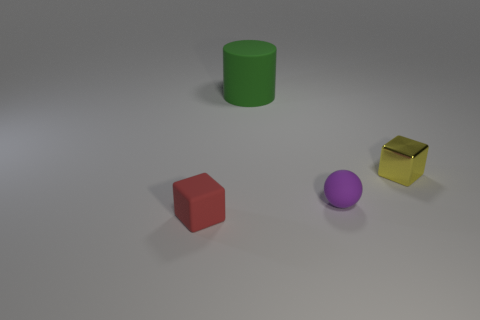There is a red rubber thing in front of the big green cylinder; what size is it?
Provide a short and direct response. Small. What is the yellow block made of?
Your answer should be compact. Metal. There is a rubber object that is to the right of the large object; is it the same shape as the big green thing?
Keep it short and to the point. No. Is there another red block of the same size as the rubber block?
Ensure brevity in your answer.  No. Are there any small shiny blocks that are to the left of the cube behind the tiny cube in front of the tiny purple matte sphere?
Your answer should be very brief. No. Do the matte cube and the block to the right of the green rubber cylinder have the same color?
Give a very brief answer. No. What material is the block in front of the tiny matte object behind the small thing that is in front of the sphere?
Provide a succinct answer. Rubber. There is a tiny rubber thing behind the tiny red thing; what shape is it?
Make the answer very short. Sphere. The cylinder that is the same material as the purple object is what size?
Provide a succinct answer. Large. What number of other small objects have the same shape as the small shiny thing?
Make the answer very short. 1. 